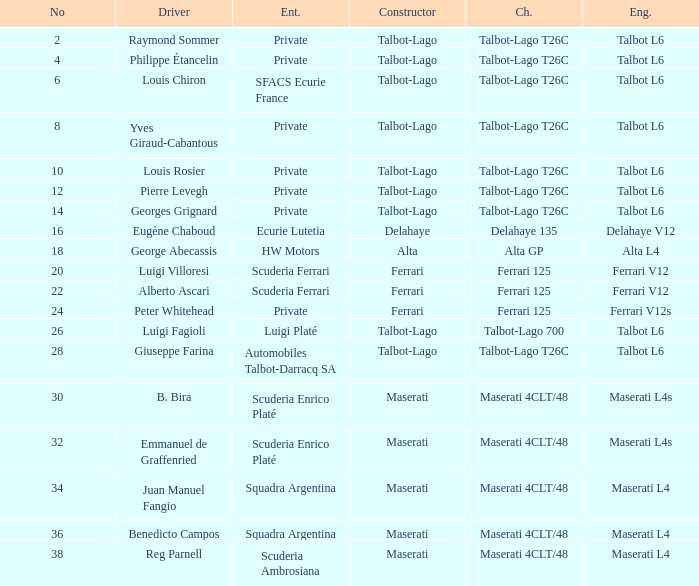Determine the maker for b. bira Maserati. 